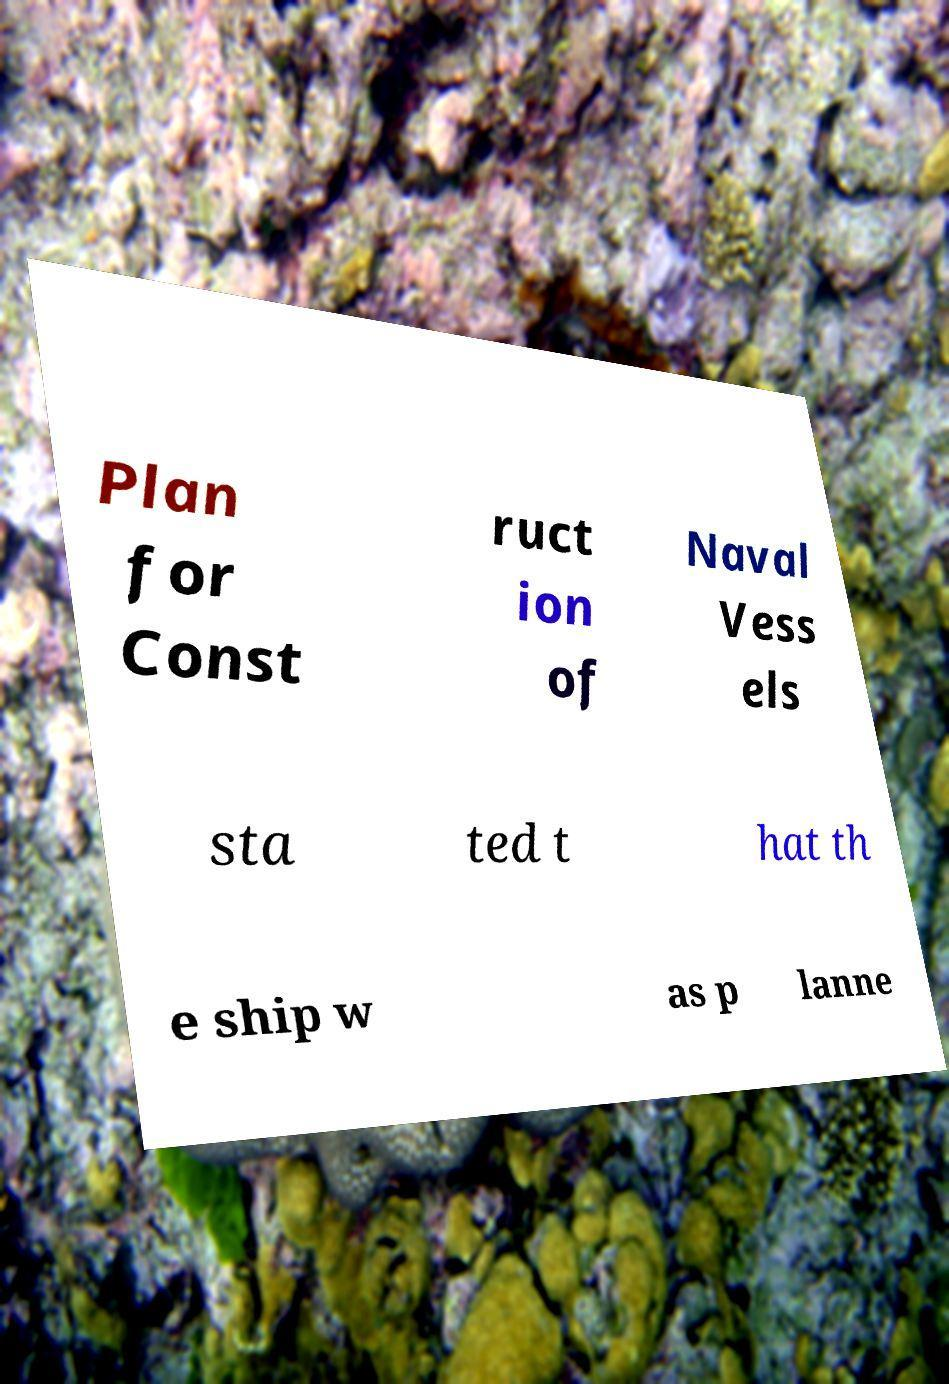For documentation purposes, I need the text within this image transcribed. Could you provide that? Plan for Const ruct ion of Naval Vess els sta ted t hat th e ship w as p lanne 